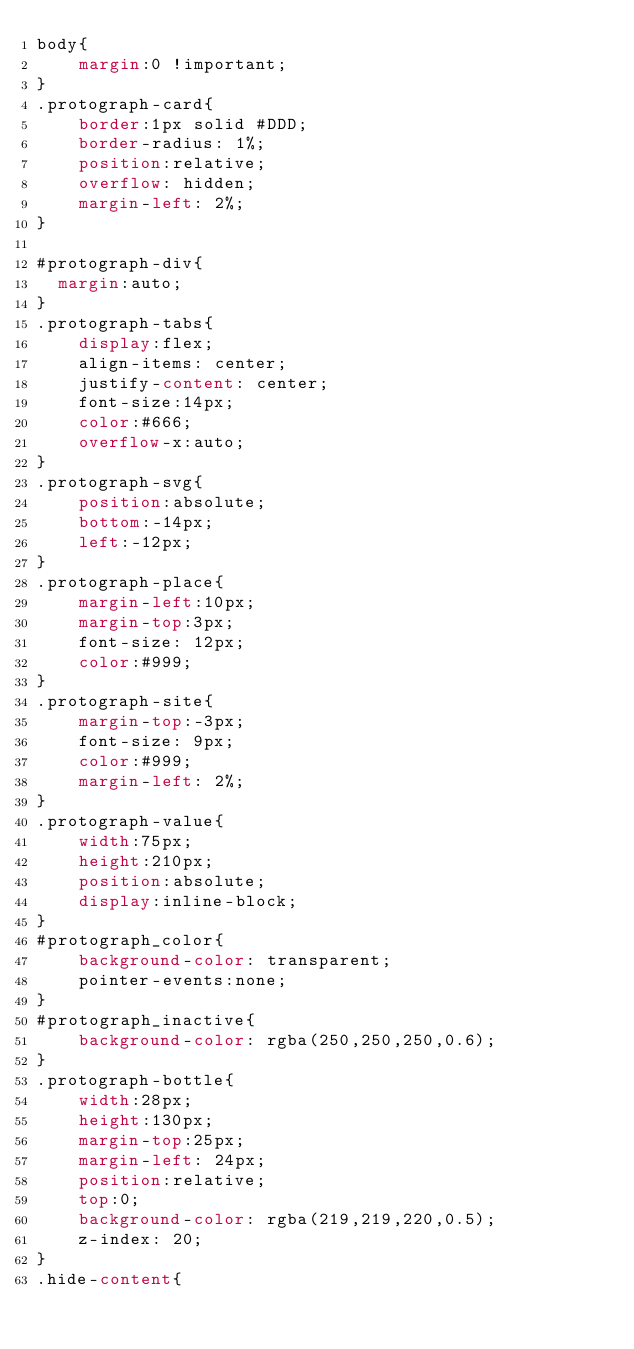<code> <loc_0><loc_0><loc_500><loc_500><_CSS_>body{
	margin:0 !important;
}
.protograph-card{
	border:1px solid #DDD;
	border-radius: 1%;
	position:relative;
	overflow: hidden;
	margin-left: 2%;
}

#protograph-div{
  margin:auto;
}
.protograph-tabs{
	display:flex;
	align-items: center;
  	justify-content: center; 
	font-size:14px;
	color:#666;
	overflow-x:auto;
}
.protograph-svg{
	position:absolute;
	bottom:-14px;
	left:-12px;
}
.protograph-place{
	margin-left:10px;
	margin-top:3px;
	font-size: 12px;
	color:#999;
}
.protograph-site{
	margin-top:-3px;
	font-size: 9px;
	color:#999;
	margin-left: 2%;
}
.protograph-value{
	width:75px;
	height:210px;
	position:absolute;
	display:inline-block;
}
#protograph_color{
	background-color: transparent;	
	pointer-events:none;
}
#protograph_inactive{
	background-color: rgba(250,250,250,0.6);	
}
.protograph-bottle{
	width:28px;
	height:130px;
	margin-top:25px;
	margin-left: 24px;
	position:relative;
	top:0;
	background-color: rgba(219,219,220,0.5);
	z-index: 20;
}
.hide-content{</code> 